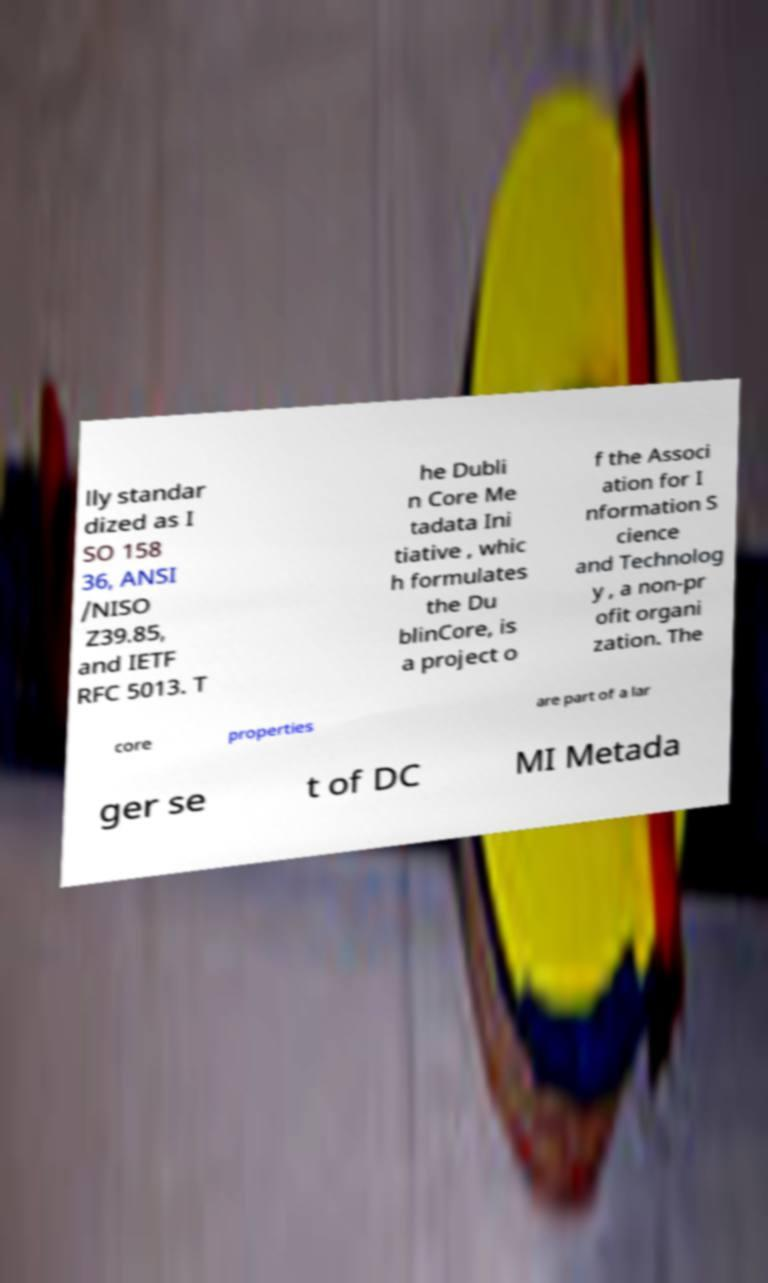I need the written content from this picture converted into text. Can you do that? lly standar dized as I SO 158 36, ANSI /NISO Z39.85, and IETF RFC 5013. T he Dubli n Core Me tadata Ini tiative , whic h formulates the Du blinCore, is a project o f the Associ ation for I nformation S cience and Technolog y , a non-pr ofit organi zation. The core properties are part of a lar ger se t of DC MI Metada 